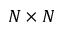<formula> <loc_0><loc_0><loc_500><loc_500>N \times N</formula> 